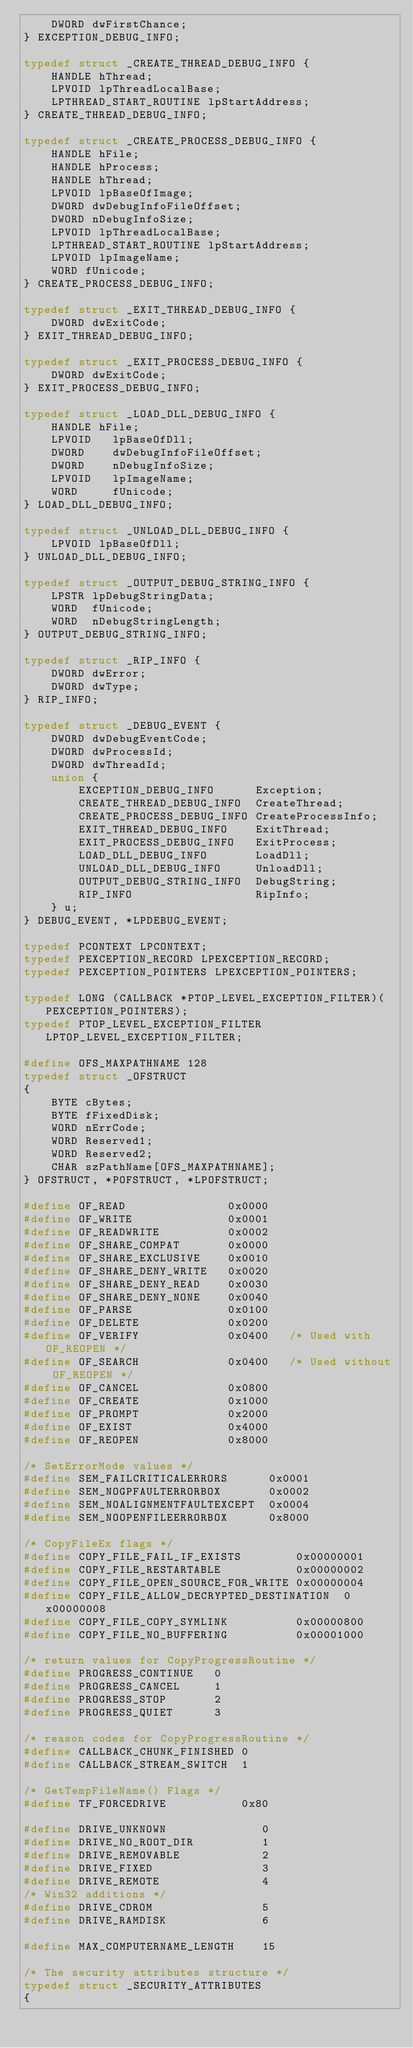Convert code to text. <code><loc_0><loc_0><loc_500><loc_500><_C_>    DWORD dwFirstChance;
} EXCEPTION_DEBUG_INFO;

typedef struct _CREATE_THREAD_DEBUG_INFO {
    HANDLE hThread;
    LPVOID lpThreadLocalBase;
    LPTHREAD_START_ROUTINE lpStartAddress;
} CREATE_THREAD_DEBUG_INFO;

typedef struct _CREATE_PROCESS_DEBUG_INFO {
    HANDLE hFile;
    HANDLE hProcess;
    HANDLE hThread;
    LPVOID lpBaseOfImage;
    DWORD dwDebugInfoFileOffset;
    DWORD nDebugInfoSize;
    LPVOID lpThreadLocalBase;
    LPTHREAD_START_ROUTINE lpStartAddress;
    LPVOID lpImageName;
    WORD fUnicode;
} CREATE_PROCESS_DEBUG_INFO;

typedef struct _EXIT_THREAD_DEBUG_INFO {
    DWORD dwExitCode;
} EXIT_THREAD_DEBUG_INFO;

typedef struct _EXIT_PROCESS_DEBUG_INFO {
    DWORD dwExitCode;
} EXIT_PROCESS_DEBUG_INFO;

typedef struct _LOAD_DLL_DEBUG_INFO {
    HANDLE hFile;
    LPVOID   lpBaseOfDll;
    DWORD    dwDebugInfoFileOffset;
    DWORD    nDebugInfoSize;
    LPVOID   lpImageName;
    WORD     fUnicode;
} LOAD_DLL_DEBUG_INFO;

typedef struct _UNLOAD_DLL_DEBUG_INFO {
    LPVOID lpBaseOfDll;
} UNLOAD_DLL_DEBUG_INFO;

typedef struct _OUTPUT_DEBUG_STRING_INFO {
    LPSTR lpDebugStringData;
    WORD  fUnicode;
    WORD  nDebugStringLength;
} OUTPUT_DEBUG_STRING_INFO;

typedef struct _RIP_INFO {
    DWORD dwError;
    DWORD dwType;
} RIP_INFO;

typedef struct _DEBUG_EVENT {
    DWORD dwDebugEventCode;
    DWORD dwProcessId;
    DWORD dwThreadId;
    union {
        EXCEPTION_DEBUG_INFO      Exception;
        CREATE_THREAD_DEBUG_INFO  CreateThread;
        CREATE_PROCESS_DEBUG_INFO CreateProcessInfo;
        EXIT_THREAD_DEBUG_INFO    ExitThread;
        EXIT_PROCESS_DEBUG_INFO   ExitProcess;
        LOAD_DLL_DEBUG_INFO       LoadDll;
        UNLOAD_DLL_DEBUG_INFO     UnloadDll;
        OUTPUT_DEBUG_STRING_INFO  DebugString;
        RIP_INFO                  RipInfo;
    } u;
} DEBUG_EVENT, *LPDEBUG_EVENT;

typedef PCONTEXT LPCONTEXT;
typedef PEXCEPTION_RECORD LPEXCEPTION_RECORD;
typedef PEXCEPTION_POINTERS LPEXCEPTION_POINTERS;

typedef LONG (CALLBACK *PTOP_LEVEL_EXCEPTION_FILTER)(PEXCEPTION_POINTERS);
typedef PTOP_LEVEL_EXCEPTION_FILTER LPTOP_LEVEL_EXCEPTION_FILTER;

#define OFS_MAXPATHNAME 128
typedef struct _OFSTRUCT
{
    BYTE cBytes;
    BYTE fFixedDisk;
    WORD nErrCode;
    WORD Reserved1;
    WORD Reserved2;
    CHAR szPathName[OFS_MAXPATHNAME];
} OFSTRUCT, *POFSTRUCT, *LPOFSTRUCT;

#define OF_READ               0x0000
#define OF_WRITE              0x0001
#define OF_READWRITE          0x0002
#define OF_SHARE_COMPAT       0x0000
#define OF_SHARE_EXCLUSIVE    0x0010
#define OF_SHARE_DENY_WRITE   0x0020
#define OF_SHARE_DENY_READ    0x0030
#define OF_SHARE_DENY_NONE    0x0040
#define OF_PARSE              0x0100
#define OF_DELETE             0x0200
#define OF_VERIFY             0x0400   /* Used with OF_REOPEN */
#define OF_SEARCH             0x0400   /* Used without OF_REOPEN */
#define OF_CANCEL             0x0800
#define OF_CREATE             0x1000
#define OF_PROMPT             0x2000
#define OF_EXIST              0x4000
#define OF_REOPEN             0x8000

/* SetErrorMode values */
#define SEM_FAILCRITICALERRORS      0x0001
#define SEM_NOGPFAULTERRORBOX       0x0002
#define SEM_NOALIGNMENTFAULTEXCEPT  0x0004
#define SEM_NOOPENFILEERRORBOX      0x8000

/* CopyFileEx flags */
#define COPY_FILE_FAIL_IF_EXISTS        0x00000001
#define COPY_FILE_RESTARTABLE           0x00000002
#define COPY_FILE_OPEN_SOURCE_FOR_WRITE 0x00000004
#define COPY_FILE_ALLOW_DECRYPTED_DESTINATION  0x00000008
#define COPY_FILE_COPY_SYMLINK          0x00000800
#define COPY_FILE_NO_BUFFERING          0x00001000

/* return values for CopyProgressRoutine */
#define PROGRESS_CONTINUE   0
#define PROGRESS_CANCEL     1
#define PROGRESS_STOP       2
#define PROGRESS_QUIET      3

/* reason codes for CopyProgressRoutine */
#define CALLBACK_CHUNK_FINISHED 0
#define CALLBACK_STREAM_SWITCH  1

/* GetTempFileName() Flags */
#define TF_FORCEDRIVE	        0x80

#define DRIVE_UNKNOWN              0
#define DRIVE_NO_ROOT_DIR          1
#define DRIVE_REMOVABLE            2
#define DRIVE_FIXED                3
#define DRIVE_REMOTE               4
/* Win32 additions */
#define DRIVE_CDROM                5
#define DRIVE_RAMDISK              6

#define MAX_COMPUTERNAME_LENGTH    15

/* The security attributes structure */
typedef struct _SECURITY_ATTRIBUTES
{</code> 